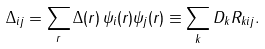Convert formula to latex. <formula><loc_0><loc_0><loc_500><loc_500>\Delta _ { i j } = \sum _ { r } \Delta ( r ) \, \psi _ { i } ( r ) \psi _ { j } ( r ) \equiv \sum _ { k } D _ { k } R _ { k i j } .</formula> 